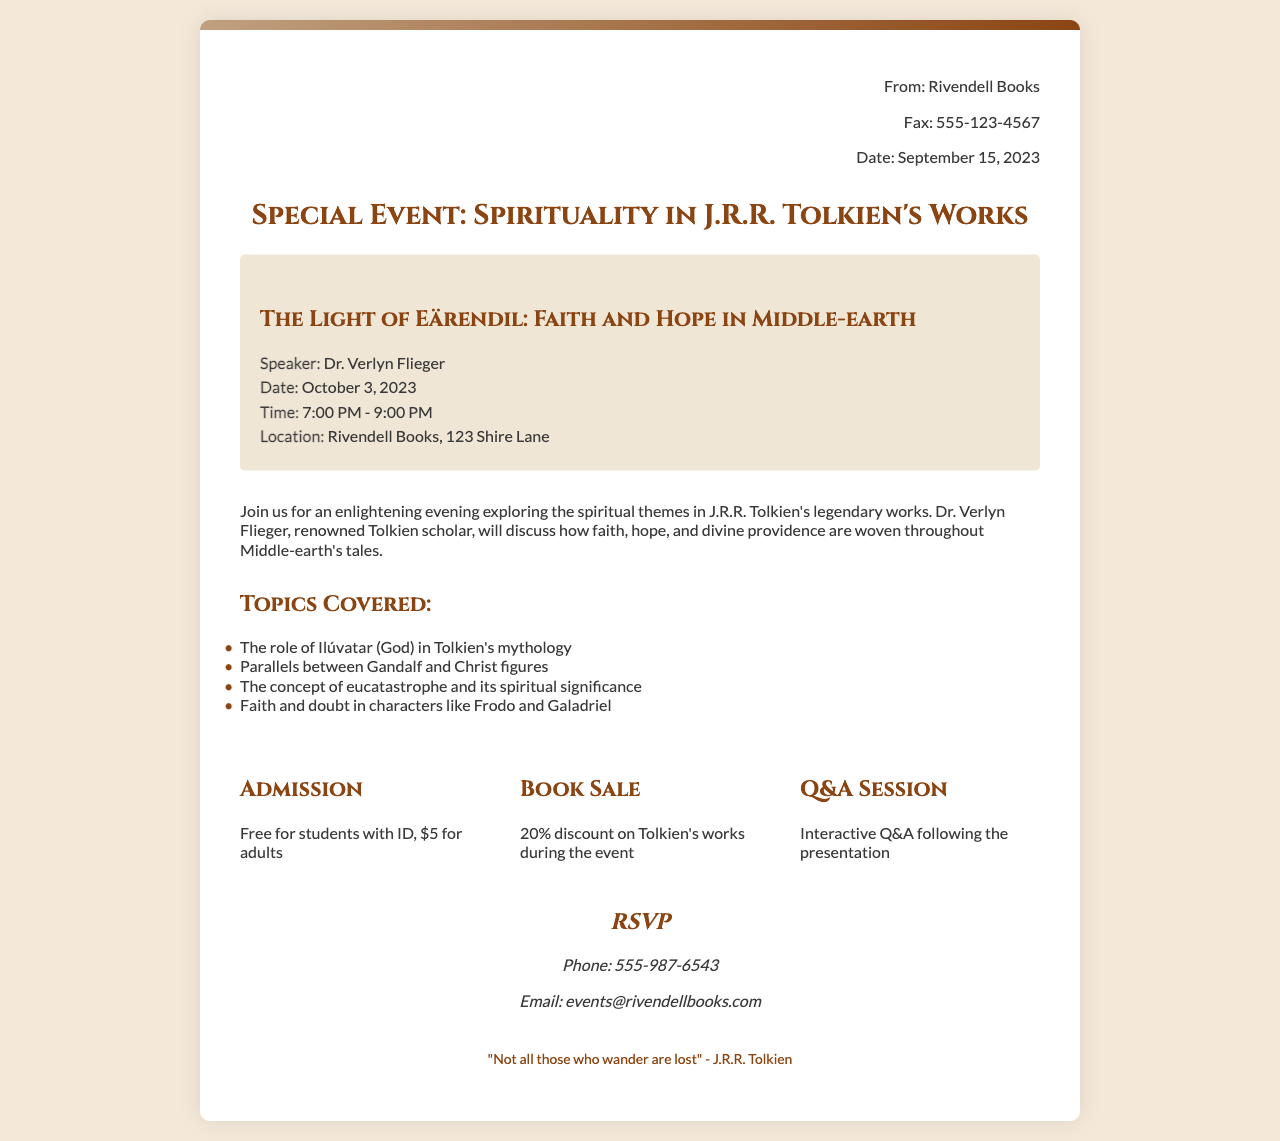What is the title of the event? The title of the event is specified in the document as "The Light of Eärendil: Faith and Hope in Middle-earth."
Answer: The Light of Eärendil: Faith and Hope in Middle-earth Who is the speaker at the event? The document lists Dr. Verlyn Flieger as the speaker for the event.
Answer: Dr. Verlyn Flieger What is the date of the event? The event date is explicitly stated in the document as October 3, 2023.
Answer: October 3, 2023 What is the admission fee for adults? The admission fee for adults is indicated in the document as $5.
Answer: $5 What are the main topics covered in the event? The main topics are outlined in the document and include themes like the role of Ilúvatar and the concept of eucatastrophe.
Answer: The role of Ilúvatar, parallels between Gandalf and Christ figures, eucatastrophe, faith and doubt in characters What is the location of the event? The location is provided in the document as Rivendell Books, 123 Shire Lane.
Answer: Rivendell Books, 123 Shire Lane Is there a discount available on books during the event? The document mentions a discount of 20% on Tolkien's works during the event, confirming availability.
Answer: 20% discount How long is the event scheduled to last? The document specifies that the event is scheduled from 7:00 PM to 9:00 PM, indicating a total duration of 2 hours.
Answer: 2 hours What kind of session follows the presentation? The document states that an interactive Q&A session will follow the presentation, indicating engagement with the audience.
Answer: Interactive Q&A 